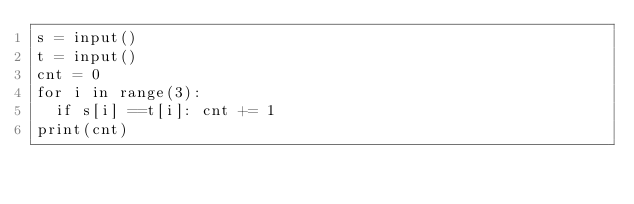Convert code to text. <code><loc_0><loc_0><loc_500><loc_500><_Python_>s = input()
t = input()
cnt = 0
for i in range(3):
  if s[i] ==t[i]: cnt += 1
print(cnt)</code> 